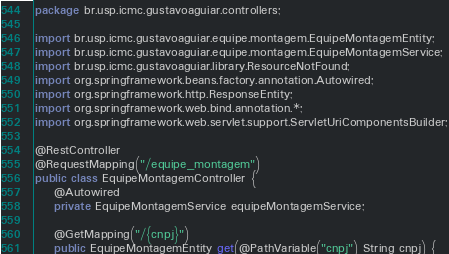<code> <loc_0><loc_0><loc_500><loc_500><_Java_>package br.usp.icmc.gustavoaguiar.controllers;

import br.usp.icmc.gustavoaguiar.equipe.montagem.EquipeMontagemEntity;
import br.usp.icmc.gustavoaguiar.equipe.montagem.EquipeMontagemService;
import br.usp.icmc.gustavoaguiar.library.ResourceNotFound;
import org.springframework.beans.factory.annotation.Autowired;
import org.springframework.http.ResponseEntity;
import org.springframework.web.bind.annotation.*;
import org.springframework.web.servlet.support.ServletUriComponentsBuilder;

@RestController
@RequestMapping("/equipe_montagem")
public class EquipeMontagemController {
    @Autowired
    private EquipeMontagemService equipeMontagemService;

    @GetMapping("/{cnpj}")
    public EquipeMontagemEntity get(@PathVariable("cnpj") String cnpj) {</code> 